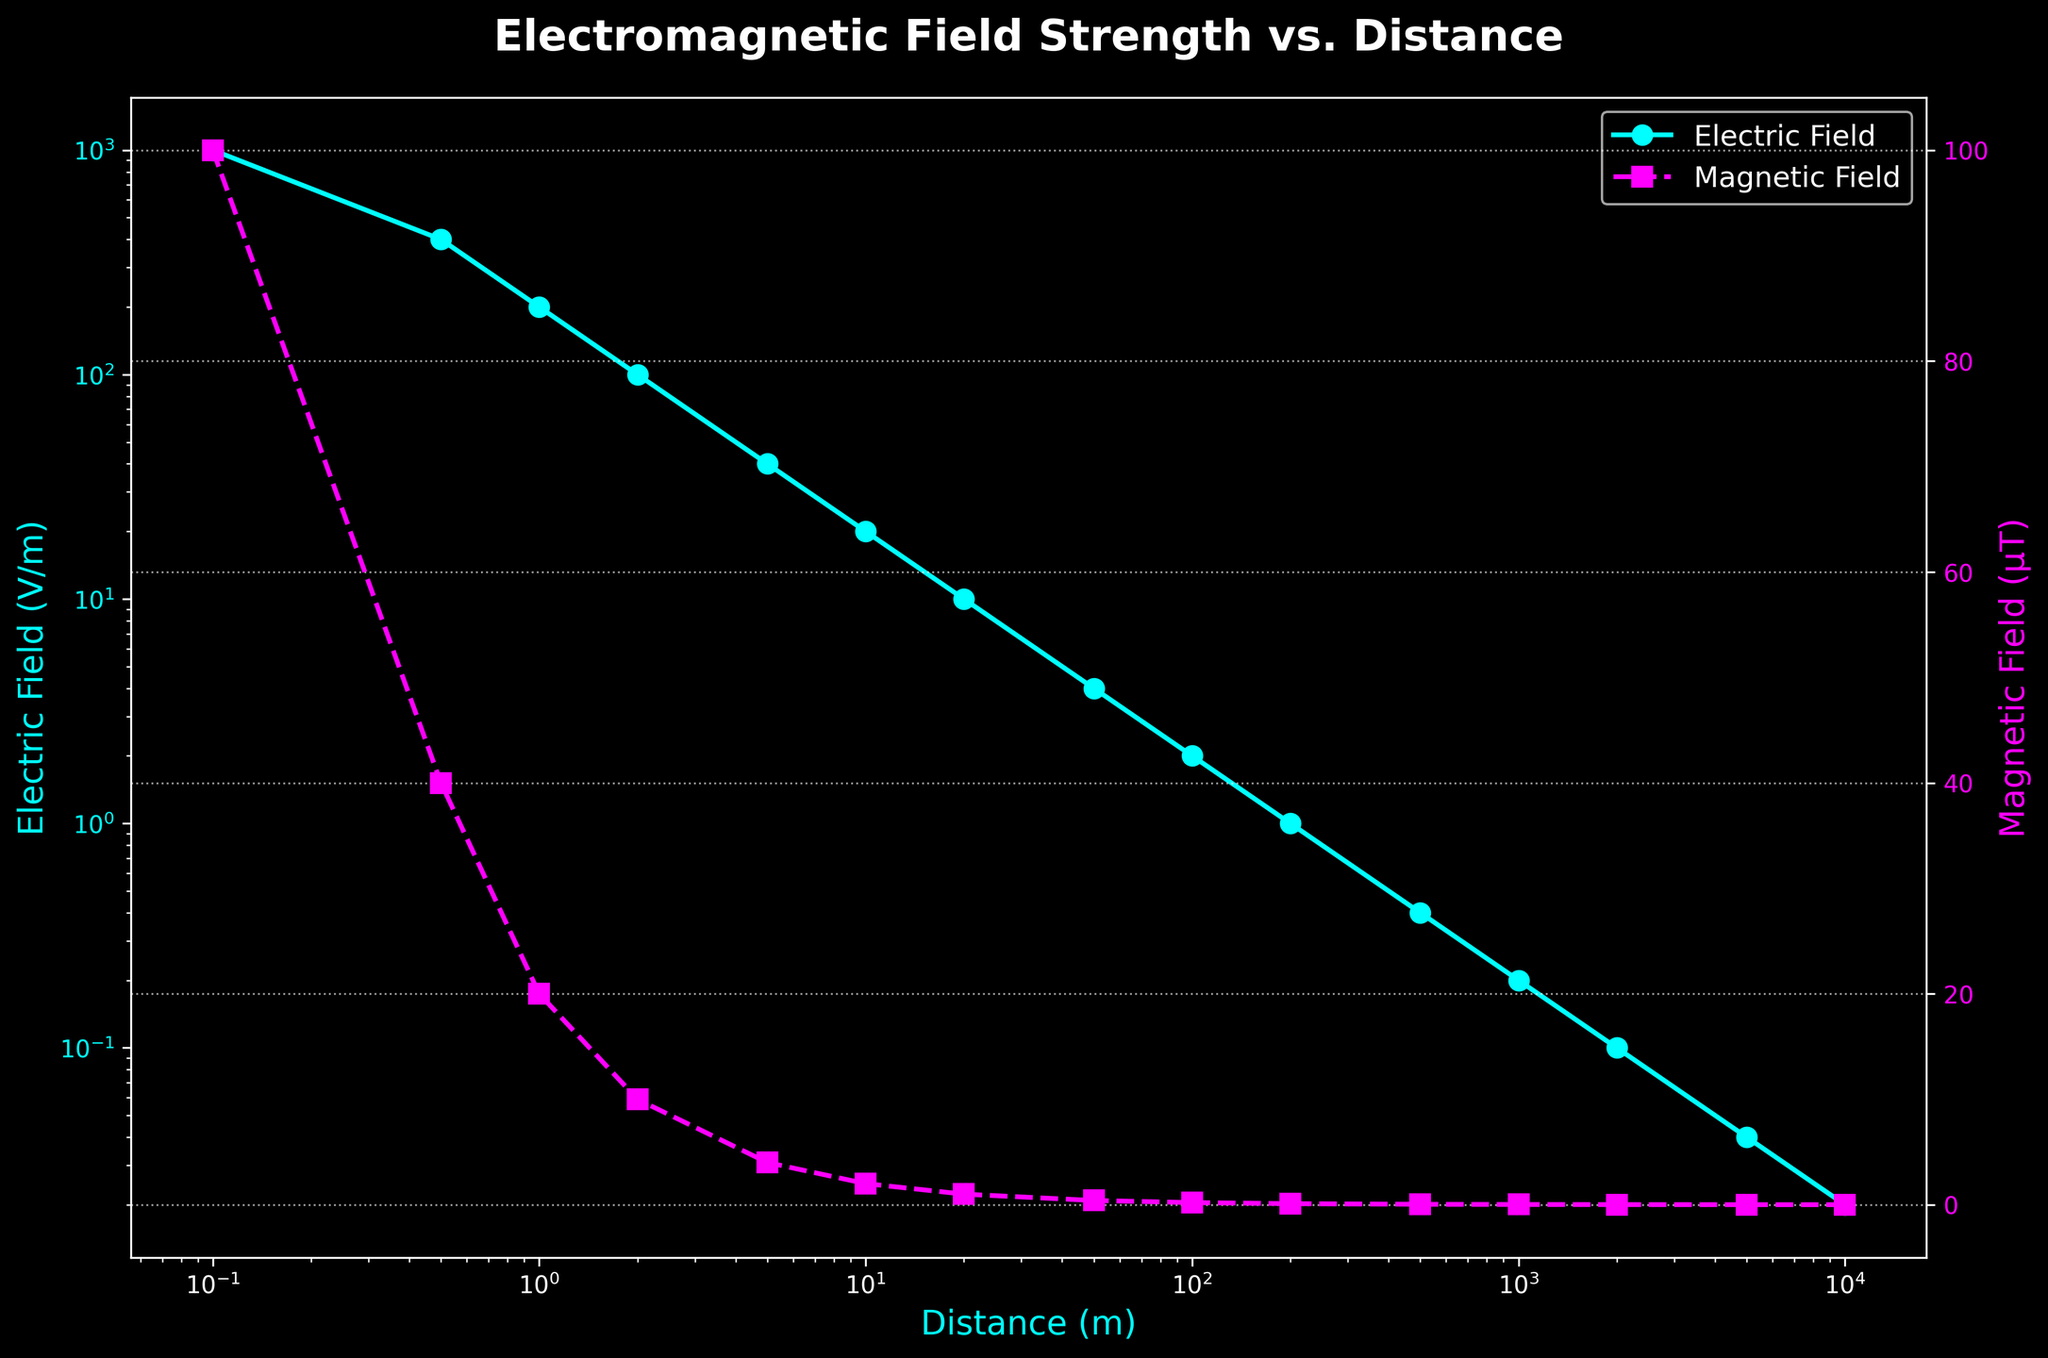What is the value of the Electric Field at a distance of 2 meters? Look for the plotted points on the Electric Field curve corresponding to 2 meters on the x-axis. The value at this point is 100 V/m.
Answer: 100 V/m Which field decreases more rapidly with distance, the Electric Field or the Magnetic Field? Both fields decrease with distance, but the slopes of their lines indicate the rate of decrease. By observing the logarithmic scale, the Electric Field decreases from 1000 V/m to 0.02 V/m, while the Magnetic Field decreases from 100 μT to 0.002 μT over the same distances. The rate of decrease (slope) appears steeper for the Electric Field.
Answer: Electric Field At what distance do the Electric and Magnetic Fields both reach a value of 1 (V/m or μT, respectively)? Observe both curves and find the distance where the respective fields intersect the value of 1 on the y-axis. The Electric Field reaches 1 V/m at 200 meters, and the Magnetic Field reaches 1 μT at 20 meters.
Answer: Only the Magnetic Field reaches 1 μT at 20 meters If the Magnetic Field value at 1 meter is doubled, what would be the new value? The current Magnetic Field value at 1 meter is 20 μT. Doubling it would result in a new value of 20 µT × 2 = 40 μT.
Answer: 40 μT How many times stronger is the Electric Field at 0.1 meter compared to at 10 meters? Find the Electric Field values at 0.1 meter (1000 V/m) and 10 meters (20 V/m), then divide the former by the latter: 1000 V/m ÷ 20 V/m = 50.
Answer: 50 times stronger What is the trend of the Magnetic Field as the distance increases from 1 meter to 1000 meters? Look at the Magnetic Field values over the distances from 1 to 1000 meters. The values are decreasing in a roughly logarithmic trend, from 20 μT at 1 meter to 0.02 μT at 1000 meters.
Answer: Decreasing trend Compare the values of the Electric Field and Magnetic Field at 5 meters. Which is higher? Identify the values at 5 meters: the Electric Field is 40 V/m and the Magnetic Field is 4 μT. The Electric Field value is higher.
Answer: Electric Field By what factor does the value of the Electric Field decrease when the distance increases from 0.5 meters to 2 meters? Determine the Electric Field values at 0.5 meters (400 V/m) and 2 meters (100 V/m). Then, find the factor by dividing the former by the latter: 400 V/m ÷ 100 V/m = 4.
Answer: Factor of 4 What color represents the Electric Field in the plot? Observe the plot's color coding for the lines. The Electric Field is represented by the light blue color.
Answer: Light blue 